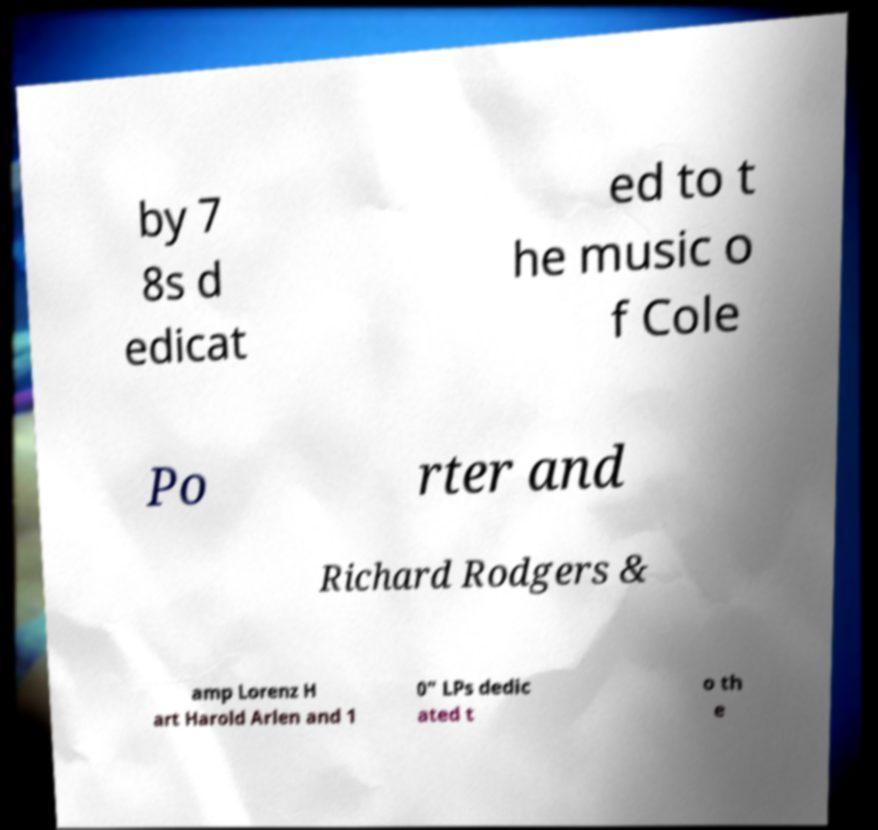Please read and relay the text visible in this image. What does it say? by 7 8s d edicat ed to t he music o f Cole Po rter and Richard Rodgers & amp Lorenz H art Harold Arlen and 1 0" LPs dedic ated t o th e 